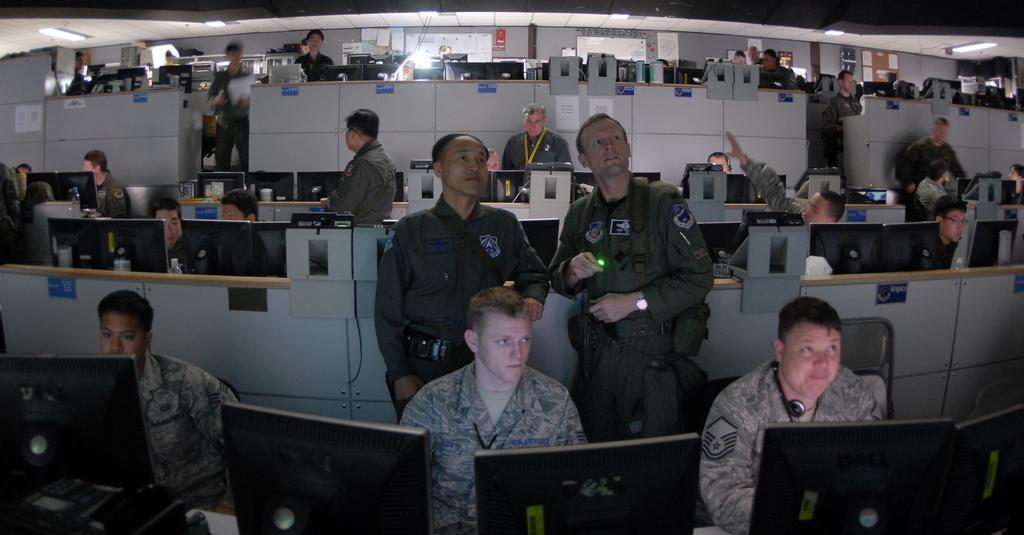Describe this image in one or two sentences. In the image there are men sitting in front of table with computers on it and few men standing in the back, it seems to be in an office. 